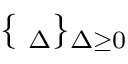<formula> <loc_0><loc_0><loc_500><loc_500>\{ { \Phi } _ { \Delta } \} _ { \Delta \geq 0 }</formula> 